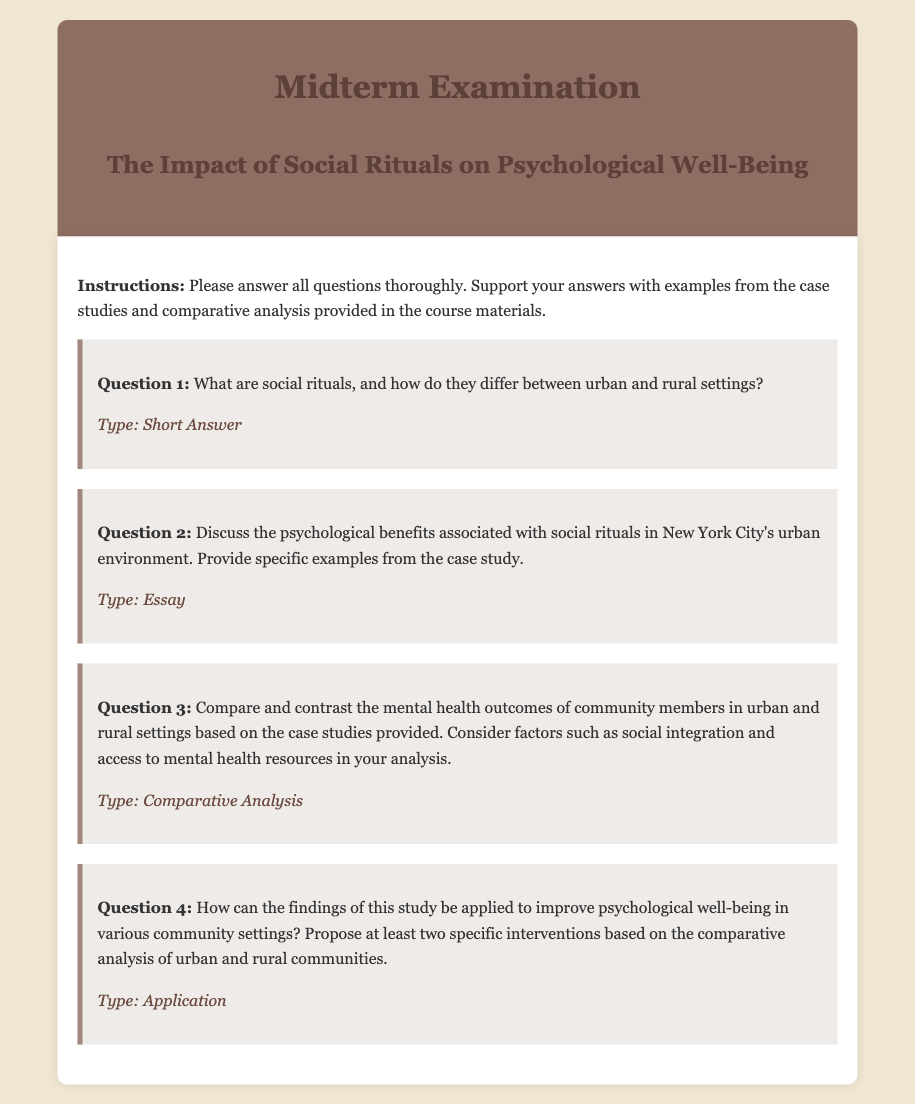What is the title of the midterm examination? The title of the midterm examination is clearly stated in the header section of the document.
Answer: The Impact of Social Rituals on Psychological Well-Being How many questions are included in the midterm examination? The document lists four distinct questions that students are required to answer.
Answer: Four What type of question is Question 1? The document categorizes each question by type, and Question 1 is noted as a short answer type.
Answer: Short Answer What are students instructed to support their answers with? The instructions specify that students should enhance their responses with specific references from the case studies and comparative analysis.
Answer: Examples from the case studies What is the background color of the exam header? The style defines the background color of the exam header, which can be identified visually.
Answer: #8d6e63 What is the primary focus of the examination? The title specifically mentions the primary topic of the examination, indicating the key focus area.
Answer: Social Rituals and Psychological Well-Being What type of question is Question 4? Each question type is labeled, and Question 4 is noted for its type.
Answer: Application What is the color of the text in the body section? The style section specifies the text color for the body, which can be inferred from the document's design.
Answer: #333 